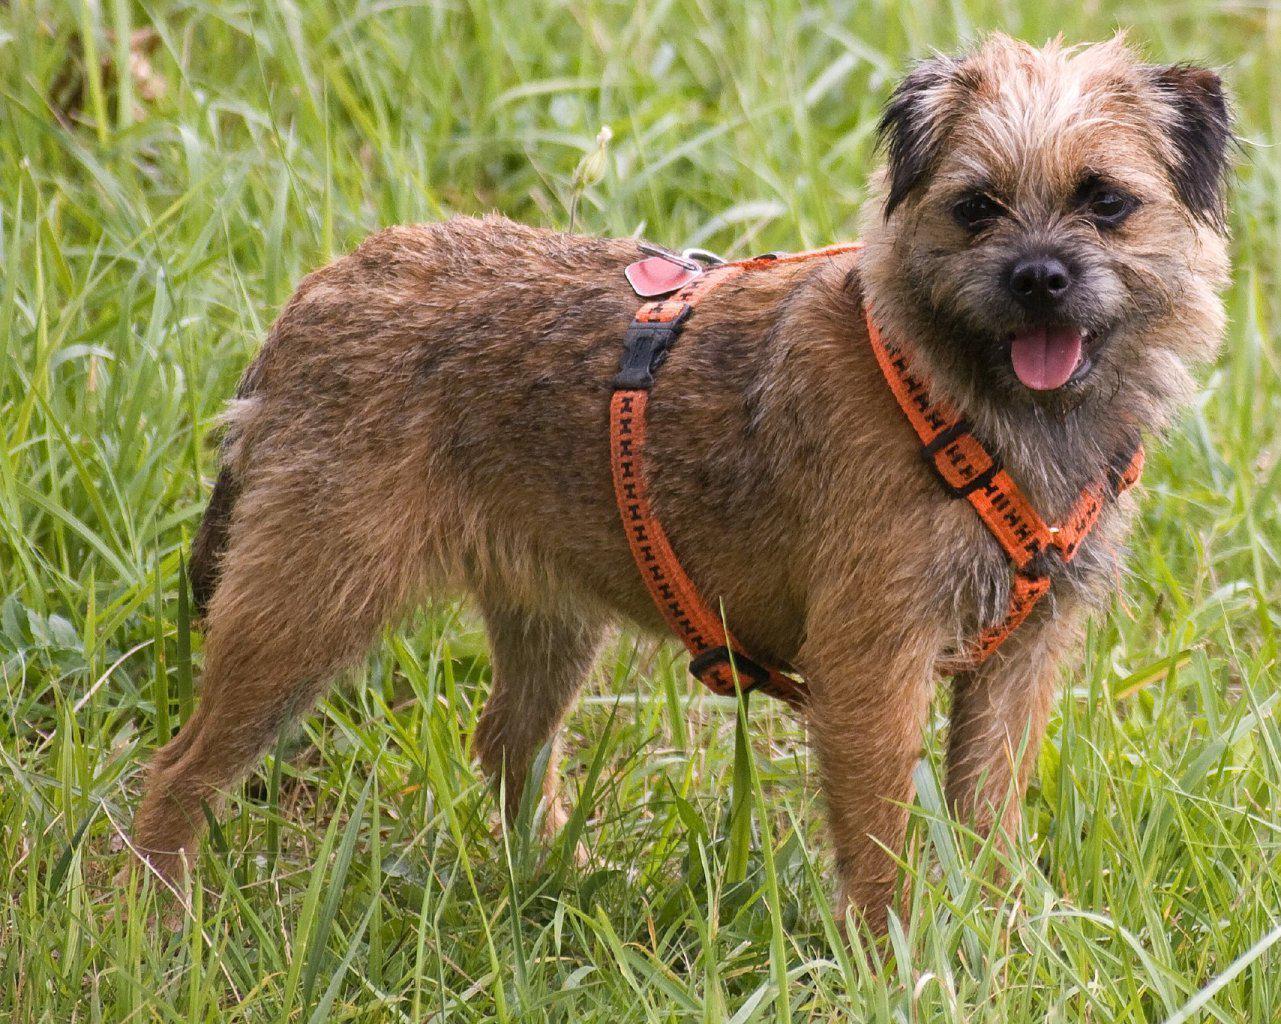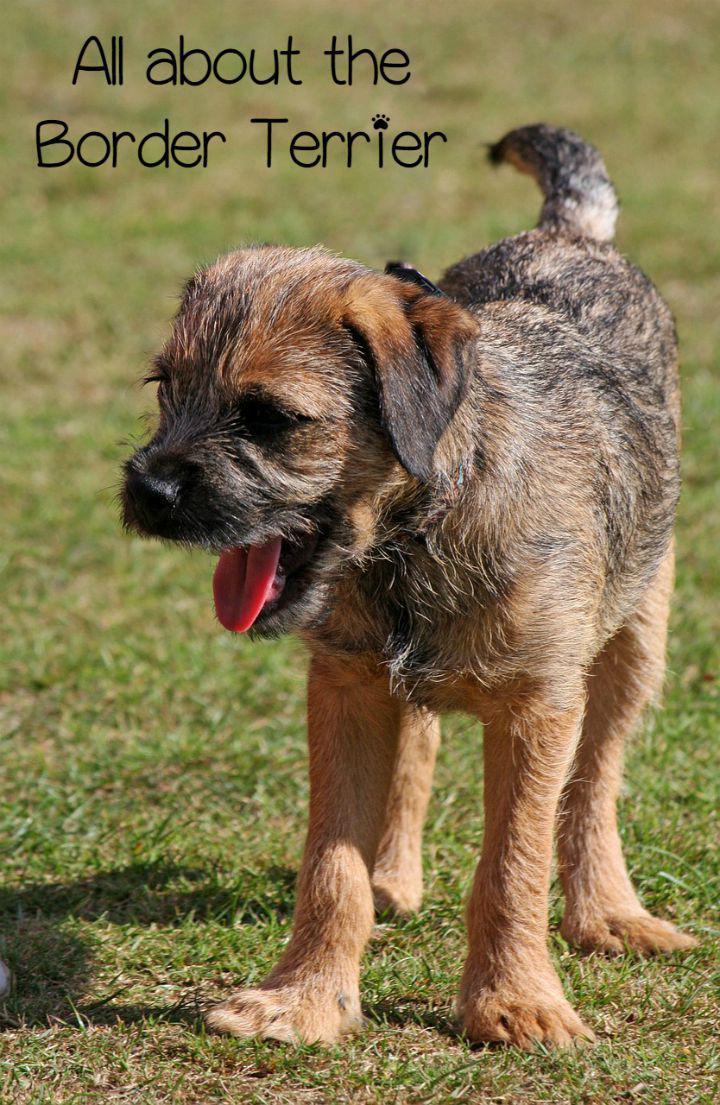The first image is the image on the left, the second image is the image on the right. For the images displayed, is the sentence "A dog stands still in profile facing left with tail extended out." factually correct? Answer yes or no. No. 